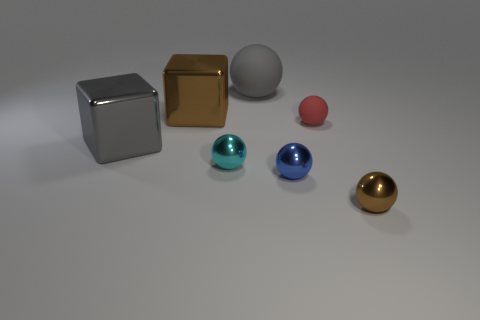Add 3 tiny blue shiny objects. How many objects exist? 10 Subtract all blocks. How many objects are left? 5 Add 2 blue shiny spheres. How many blue shiny spheres are left? 3 Add 5 blue metallic objects. How many blue metallic objects exist? 6 Subtract 0 purple cubes. How many objects are left? 7 Subtract all big green matte blocks. Subtract all tiny blue objects. How many objects are left? 6 